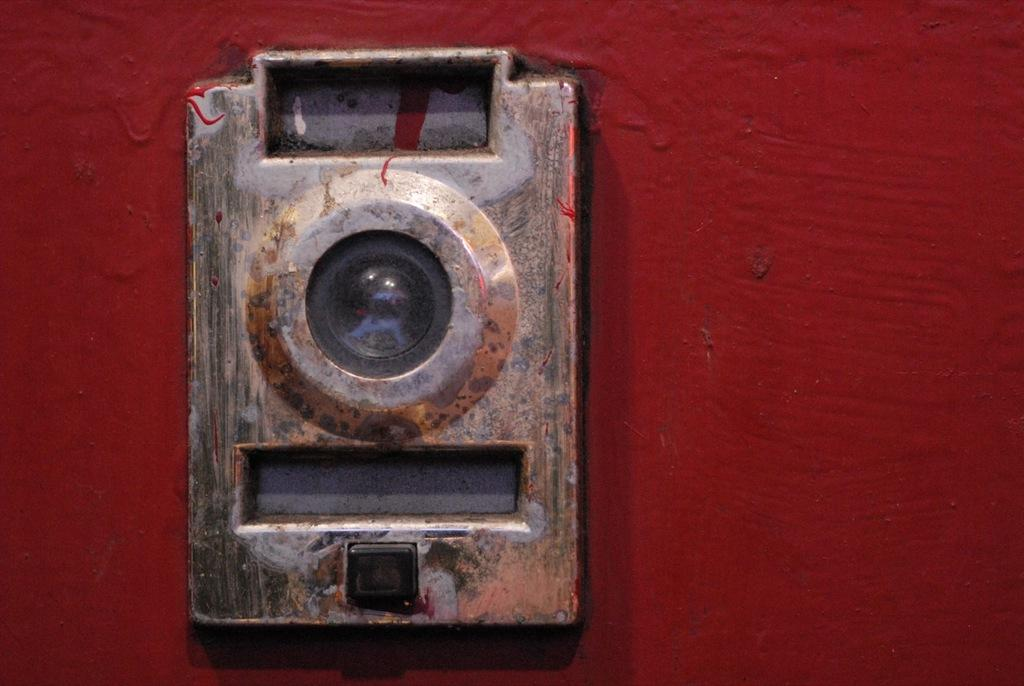What can be seen in the image? There is an object in the image. How many fairies are flying around the object in the image? There are no fairies present in the image. What type of currency can be seen near the object in the image? There is no currency visible in the image. 